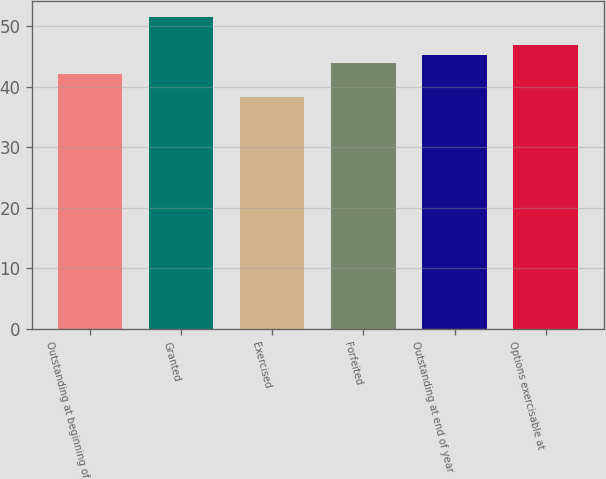Convert chart. <chart><loc_0><loc_0><loc_500><loc_500><bar_chart><fcel>Outstanding at beginning of<fcel>Granted<fcel>Exercised<fcel>Forfeited<fcel>Outstanding at end of year<fcel>Options exercisable at<nl><fcel>42.21<fcel>51.62<fcel>38.3<fcel>43.9<fcel>45.23<fcel>46.95<nl></chart> 